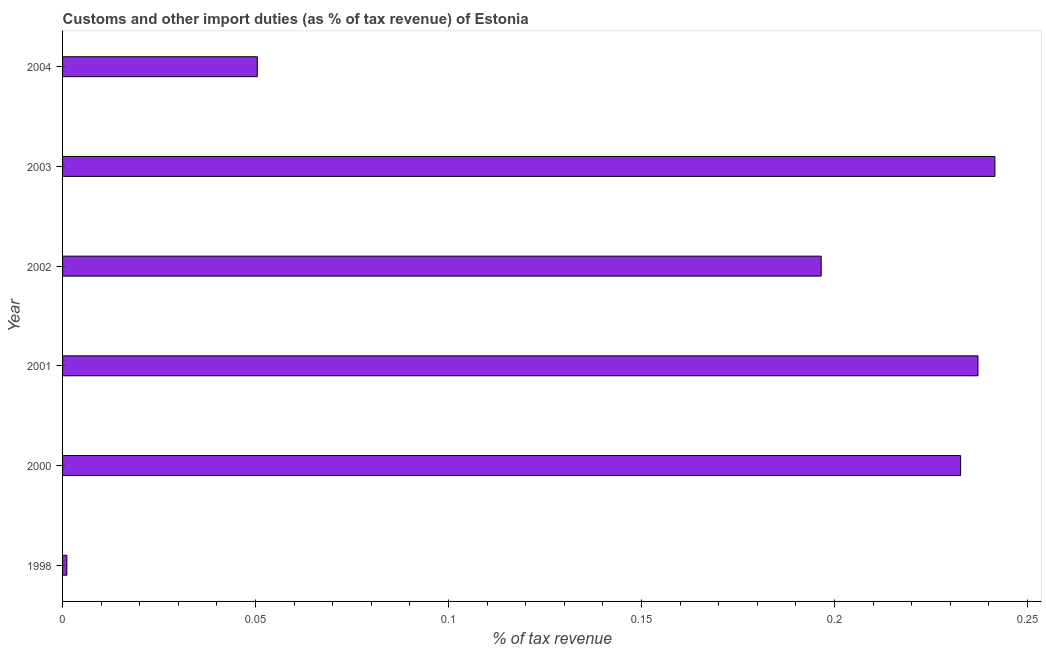What is the title of the graph?
Provide a succinct answer. Customs and other import duties (as % of tax revenue) of Estonia. What is the label or title of the X-axis?
Ensure brevity in your answer.  % of tax revenue. What is the customs and other import duties in 2004?
Your answer should be compact. 0.05. Across all years, what is the maximum customs and other import duties?
Provide a succinct answer. 0.24. Across all years, what is the minimum customs and other import duties?
Give a very brief answer. 0. In which year was the customs and other import duties maximum?
Provide a short and direct response. 2003. In which year was the customs and other import duties minimum?
Provide a short and direct response. 1998. What is the sum of the customs and other import duties?
Provide a short and direct response. 0.96. What is the difference between the customs and other import duties in 1998 and 2003?
Offer a very short reply. -0.24. What is the average customs and other import duties per year?
Offer a very short reply. 0.16. What is the median customs and other import duties?
Your response must be concise. 0.21. In how many years, is the customs and other import duties greater than 0.02 %?
Offer a very short reply. 5. Do a majority of the years between 2002 and 2004 (inclusive) have customs and other import duties greater than 0.1 %?
Provide a short and direct response. Yes. What is the ratio of the customs and other import duties in 2000 to that in 2002?
Give a very brief answer. 1.18. Is the customs and other import duties in 2003 less than that in 2004?
Offer a very short reply. No. What is the difference between the highest and the second highest customs and other import duties?
Your answer should be compact. 0. Is the sum of the customs and other import duties in 2000 and 2001 greater than the maximum customs and other import duties across all years?
Ensure brevity in your answer.  Yes. What is the difference between the highest and the lowest customs and other import duties?
Your response must be concise. 0.24. Are all the bars in the graph horizontal?
Keep it short and to the point. Yes. Are the values on the major ticks of X-axis written in scientific E-notation?
Provide a short and direct response. No. What is the % of tax revenue in 1998?
Make the answer very short. 0. What is the % of tax revenue of 2000?
Provide a succinct answer. 0.23. What is the % of tax revenue of 2001?
Ensure brevity in your answer.  0.24. What is the % of tax revenue in 2002?
Your answer should be very brief. 0.2. What is the % of tax revenue of 2003?
Offer a very short reply. 0.24. What is the % of tax revenue of 2004?
Make the answer very short. 0.05. What is the difference between the % of tax revenue in 1998 and 2000?
Keep it short and to the point. -0.23. What is the difference between the % of tax revenue in 1998 and 2001?
Give a very brief answer. -0.24. What is the difference between the % of tax revenue in 1998 and 2002?
Give a very brief answer. -0.2. What is the difference between the % of tax revenue in 1998 and 2003?
Your answer should be very brief. -0.24. What is the difference between the % of tax revenue in 1998 and 2004?
Give a very brief answer. -0.05. What is the difference between the % of tax revenue in 2000 and 2001?
Make the answer very short. -0. What is the difference between the % of tax revenue in 2000 and 2002?
Give a very brief answer. 0.04. What is the difference between the % of tax revenue in 2000 and 2003?
Provide a succinct answer. -0.01. What is the difference between the % of tax revenue in 2000 and 2004?
Your response must be concise. 0.18. What is the difference between the % of tax revenue in 2001 and 2002?
Your answer should be very brief. 0.04. What is the difference between the % of tax revenue in 2001 and 2003?
Your answer should be compact. -0. What is the difference between the % of tax revenue in 2001 and 2004?
Keep it short and to the point. 0.19. What is the difference between the % of tax revenue in 2002 and 2003?
Your answer should be compact. -0.04. What is the difference between the % of tax revenue in 2002 and 2004?
Provide a succinct answer. 0.15. What is the difference between the % of tax revenue in 2003 and 2004?
Your response must be concise. 0.19. What is the ratio of the % of tax revenue in 1998 to that in 2000?
Give a very brief answer. 0.01. What is the ratio of the % of tax revenue in 1998 to that in 2001?
Your answer should be compact. 0.01. What is the ratio of the % of tax revenue in 1998 to that in 2002?
Your answer should be compact. 0.01. What is the ratio of the % of tax revenue in 1998 to that in 2003?
Your response must be concise. 0.01. What is the ratio of the % of tax revenue in 1998 to that in 2004?
Offer a very short reply. 0.02. What is the ratio of the % of tax revenue in 2000 to that in 2002?
Your answer should be very brief. 1.18. What is the ratio of the % of tax revenue in 2000 to that in 2003?
Your answer should be very brief. 0.96. What is the ratio of the % of tax revenue in 2000 to that in 2004?
Keep it short and to the point. 4.61. What is the ratio of the % of tax revenue in 2001 to that in 2002?
Provide a succinct answer. 1.21. What is the ratio of the % of tax revenue in 2001 to that in 2004?
Your answer should be compact. 4.7. What is the ratio of the % of tax revenue in 2002 to that in 2003?
Provide a succinct answer. 0.81. What is the ratio of the % of tax revenue in 2002 to that in 2004?
Ensure brevity in your answer.  3.9. What is the ratio of the % of tax revenue in 2003 to that in 2004?
Offer a terse response. 4.79. 